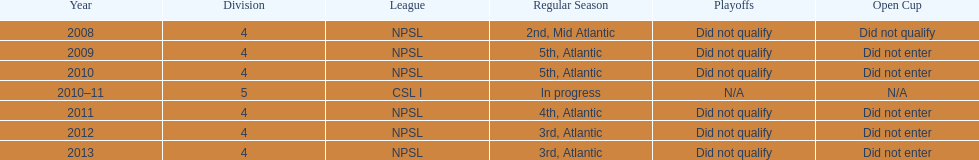When was the final year they achieved a 5th place position? 2010. 